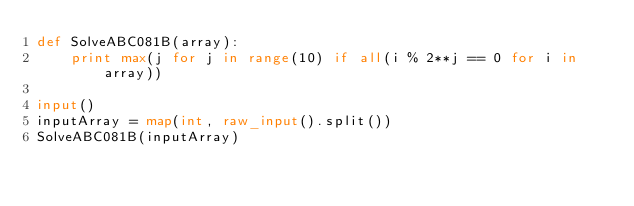Convert code to text. <code><loc_0><loc_0><loc_500><loc_500><_Python_>def SolveABC081B(array):
    print max(j for j in range(10) if all(i % 2**j == 0 for i in array))
    
input()
inputArray = map(int, raw_input().split())
SolveABC081B(inputArray)</code> 